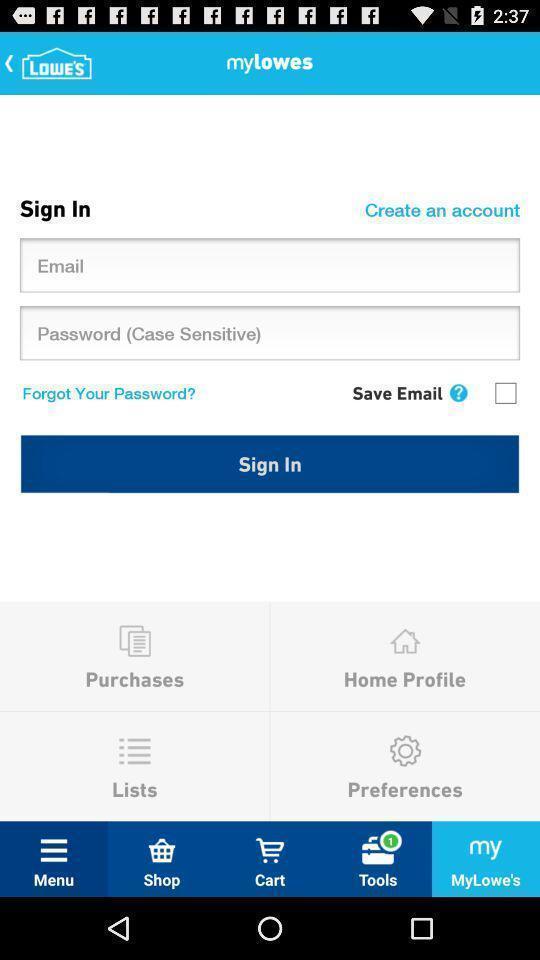What details can you identify in this image? Sign in tab. 